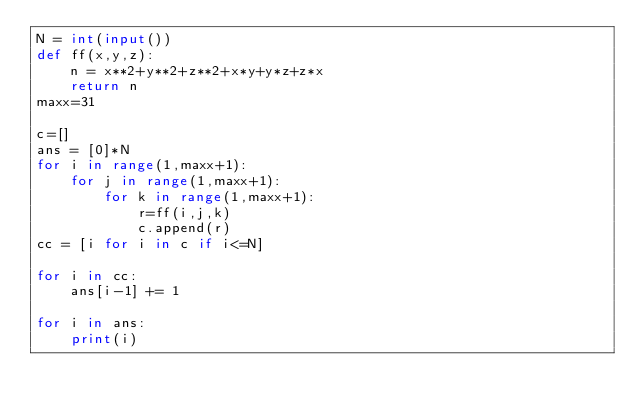<code> <loc_0><loc_0><loc_500><loc_500><_Python_>N = int(input())
def ff(x,y,z):
    n = x**2+y**2+z**2+x*y+y*z+z*x
    return n
maxx=31

c=[]
ans = [0]*N
for i in range(1,maxx+1):
    for j in range(1,maxx+1):
        for k in range(1,maxx+1):
            r=ff(i,j,k)
            c.append(r)
cc = [i for i in c if i<=N]

for i in cc:
    ans[i-1] += 1

for i in ans:
    print(i)</code> 